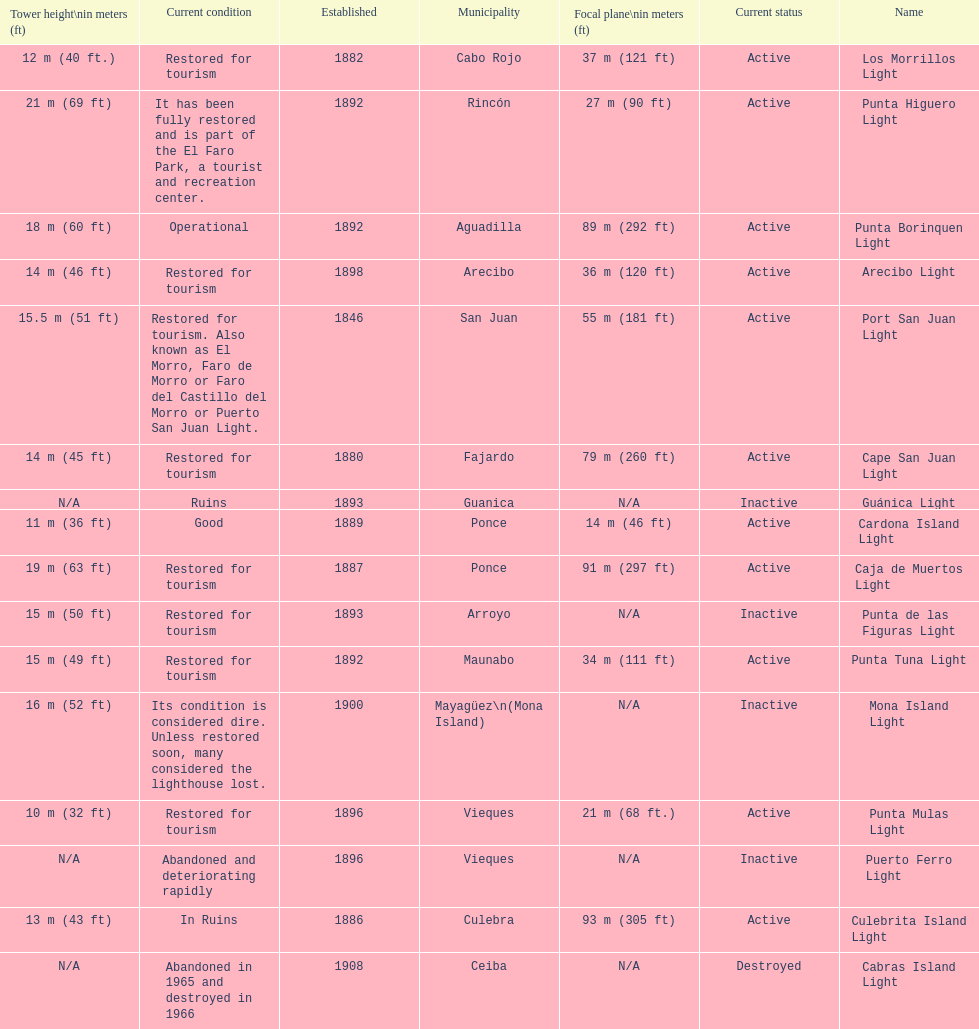Which municipality was the first to be established? San Juan. 